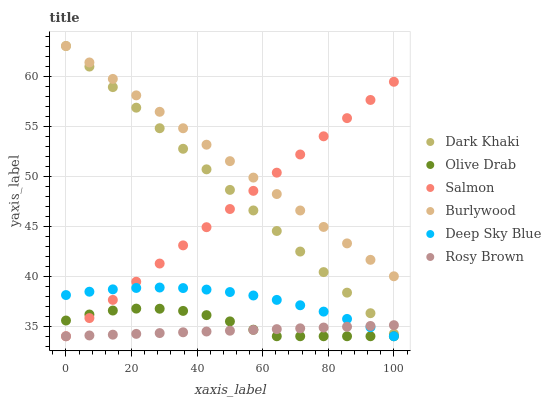Does Rosy Brown have the minimum area under the curve?
Answer yes or no. Yes. Does Burlywood have the maximum area under the curve?
Answer yes or no. Yes. Does Salmon have the minimum area under the curve?
Answer yes or no. No. Does Salmon have the maximum area under the curve?
Answer yes or no. No. Is Dark Khaki the smoothest?
Answer yes or no. Yes. Is Olive Drab the roughest?
Answer yes or no. Yes. Is Rosy Brown the smoothest?
Answer yes or no. No. Is Rosy Brown the roughest?
Answer yes or no. No. Does Rosy Brown have the lowest value?
Answer yes or no. Yes. Does Dark Khaki have the lowest value?
Answer yes or no. No. Does Dark Khaki have the highest value?
Answer yes or no. Yes. Does Salmon have the highest value?
Answer yes or no. No. Is Rosy Brown less than Burlywood?
Answer yes or no. Yes. Is Burlywood greater than Olive Drab?
Answer yes or no. Yes. Does Dark Khaki intersect Rosy Brown?
Answer yes or no. Yes. Is Dark Khaki less than Rosy Brown?
Answer yes or no. No. Is Dark Khaki greater than Rosy Brown?
Answer yes or no. No. Does Rosy Brown intersect Burlywood?
Answer yes or no. No. 